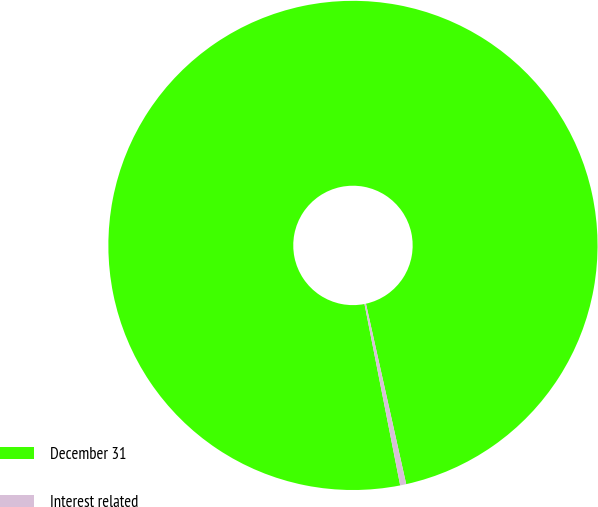Convert chart to OTSL. <chart><loc_0><loc_0><loc_500><loc_500><pie_chart><fcel>December 31<fcel>Interest related<nl><fcel>99.6%<fcel>0.4%<nl></chart> 